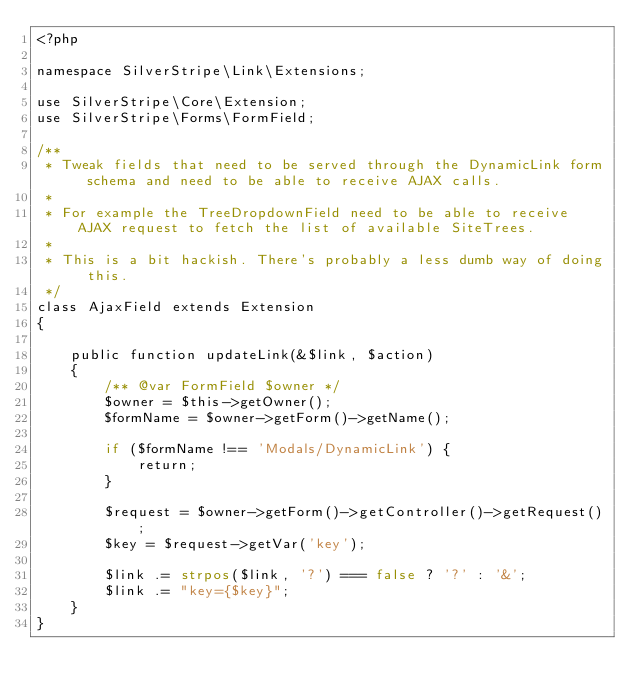Convert code to text. <code><loc_0><loc_0><loc_500><loc_500><_PHP_><?php

namespace SilverStripe\Link\Extensions;

use SilverStripe\Core\Extension;
use SilverStripe\Forms\FormField;

/**
 * Tweak fields that need to be served through the DynamicLink form schema and need to be able to receive AJAX calls.
 *
 * For example the TreeDropdownField need to be able to receive AJAX request to fetch the list of available SiteTrees.
 *
 * This is a bit hackish. There's probably a less dumb way of doing this.
 */
class AjaxField extends Extension
{

    public function updateLink(&$link, $action)
    {
        /** @var FormField $owner */
        $owner = $this->getOwner();
        $formName = $owner->getForm()->getName();

        if ($formName !== 'Modals/DynamicLink') {
            return;
        }

        $request = $owner->getForm()->getController()->getRequest();
        $key = $request->getVar('key');

        $link .= strpos($link, '?') === false ? '?' : '&';
        $link .= "key={$key}";
    }
}
</code> 